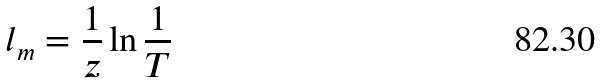<formula> <loc_0><loc_0><loc_500><loc_500>l _ { m } = \frac { 1 } { z } \ln \frac { 1 } { T }</formula> 